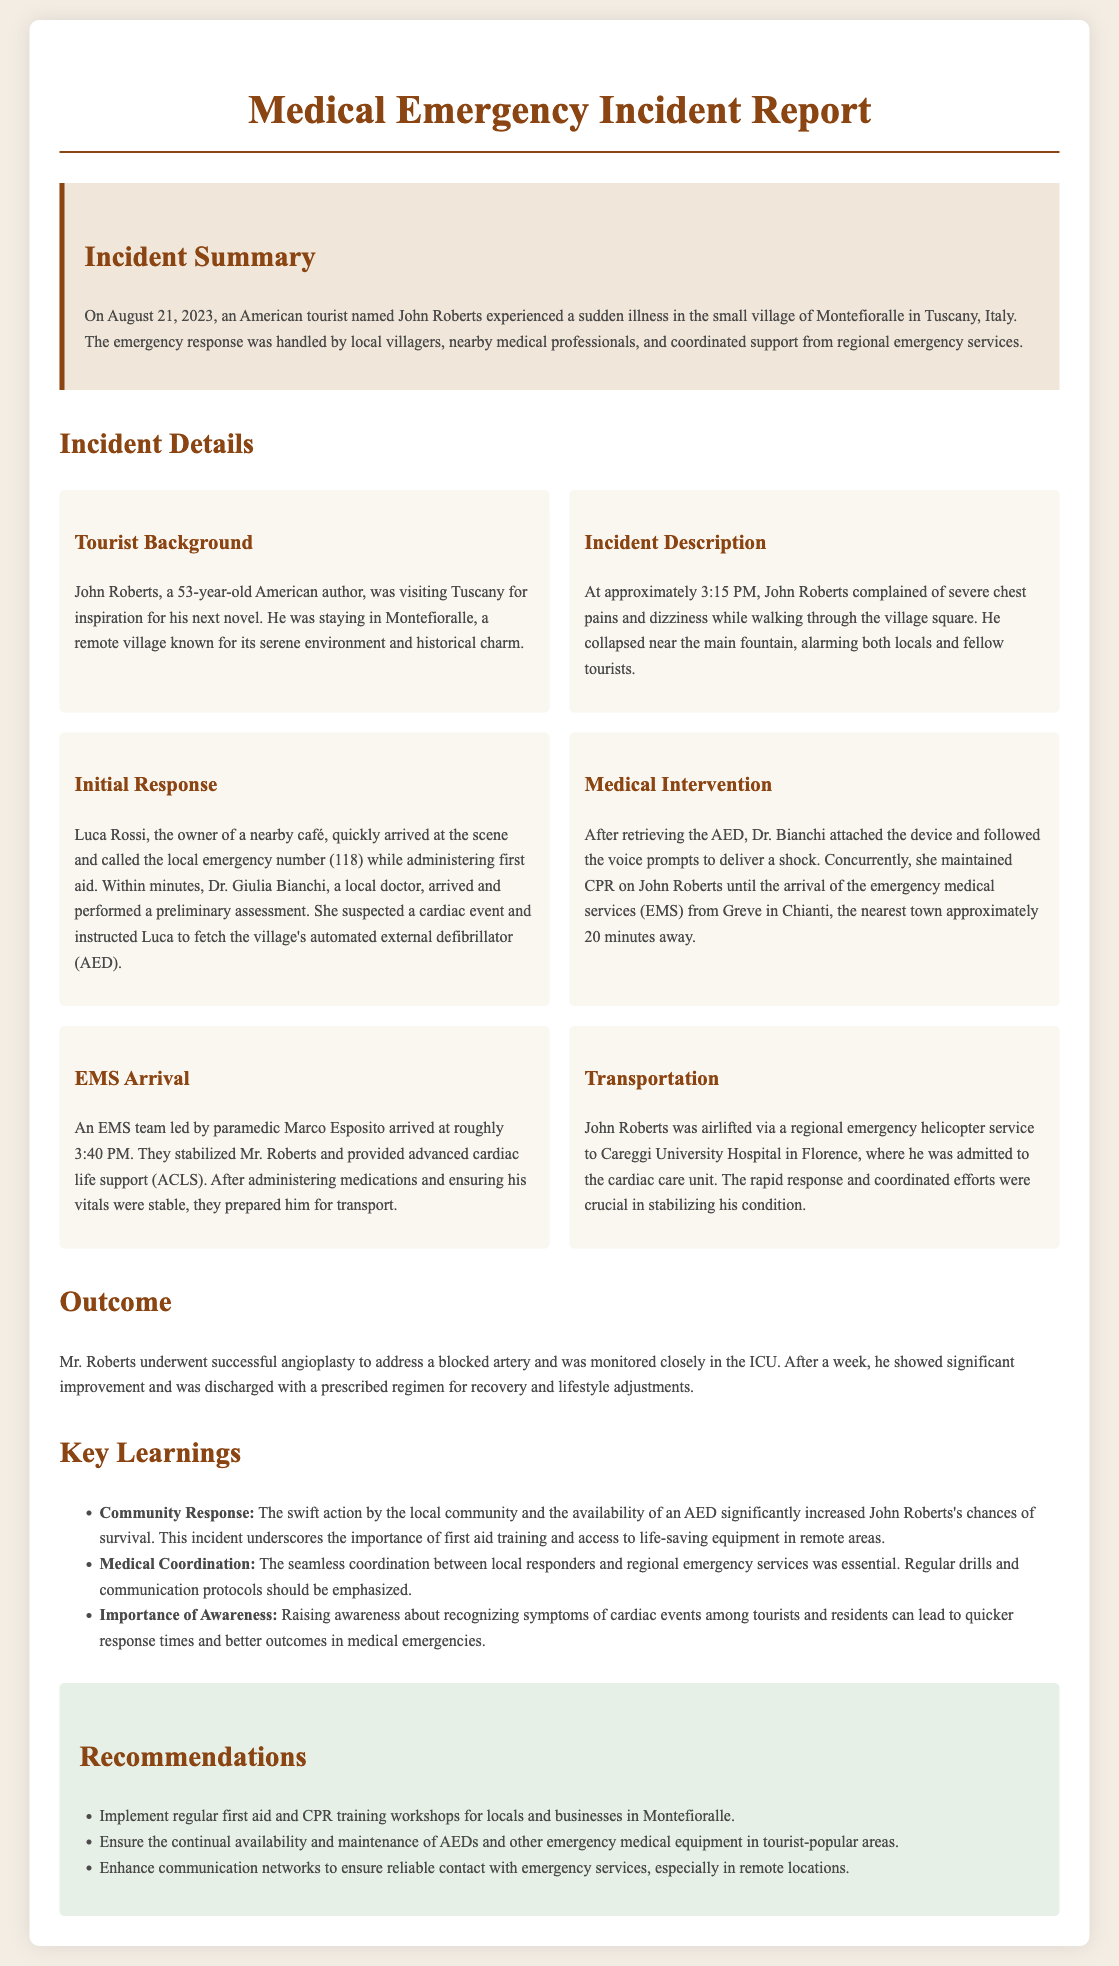what is the name of the tourist involved in the incident? The document states that the tourist's name is John Roberts.
Answer: John Roberts when did the incident occur? The document specifies that the incident occurred on August 21, 2023.
Answer: August 21, 2023 what were the symptoms experienced by John Roberts? The symptoms mentioned include severe chest pains and dizziness.
Answer: severe chest pains and dizziness who provided the initial medical response? According to the document, Luca Rossi, the owner of a nearby café, provided the initial response.
Answer: Luca Rossi what medical procedure did John Roberts undergo? The document notes that John Roberts underwent successful angioplasty.
Answer: angioplasty how long after the incident did the EMS team arrive? The EMS team arrived approximately 25 minutes after the incident started, around 3:40 PM.
Answer: 25 minutes what was crucial in stabilizing John Roberts's condition? The document highlights that the rapid response and coordinated efforts were crucial in stabilizing his condition.
Answer: rapid response and coordinated efforts what is one of the key learnings from the incident? The document mentions that swift action by the local community significantly increased John Roberts's chances of survival.
Answer: swift action by the local community 